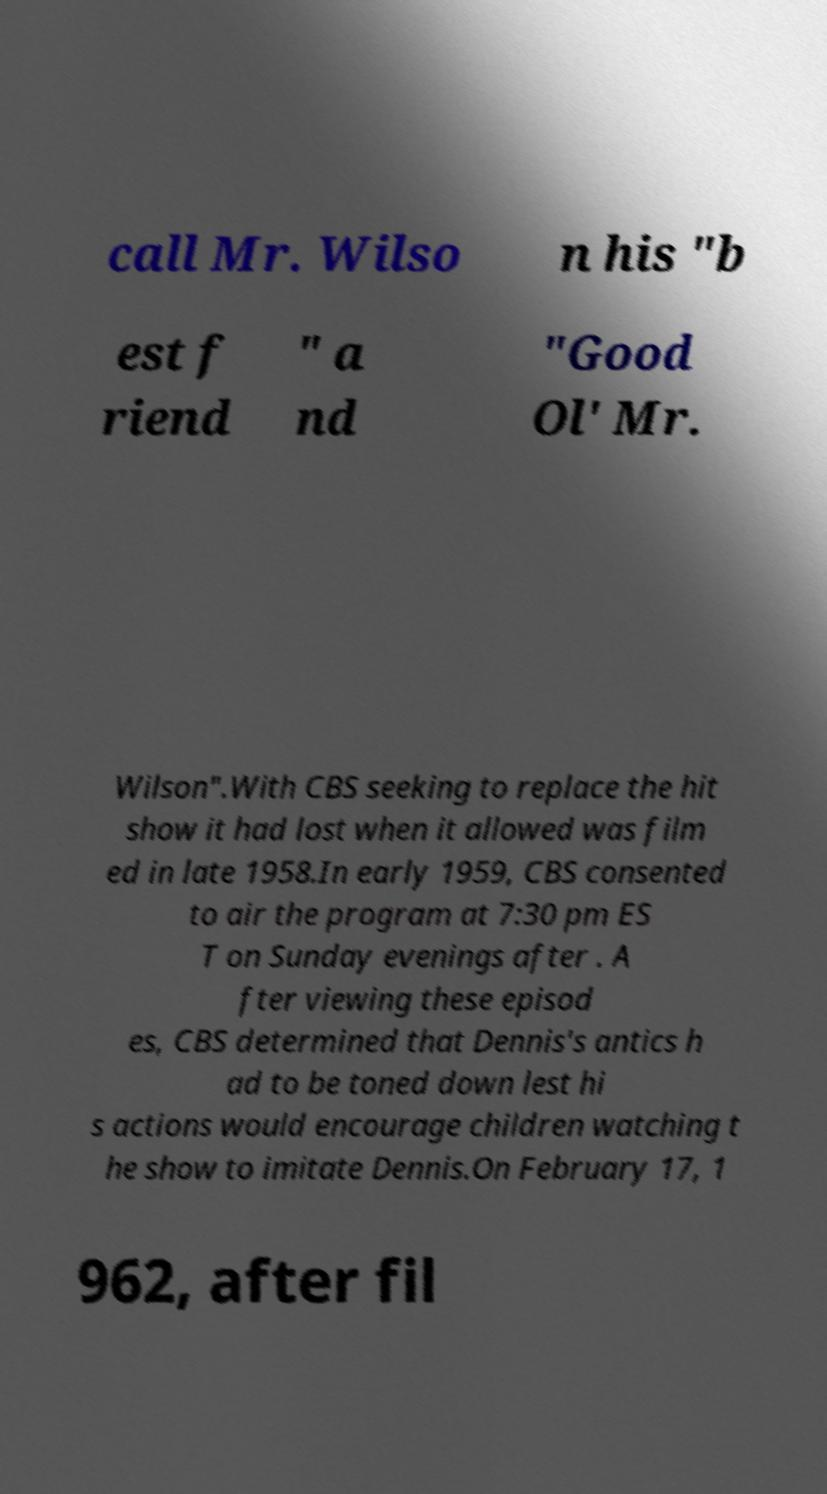What messages or text are displayed in this image? I need them in a readable, typed format. call Mr. Wilso n his "b est f riend " a nd "Good Ol' Mr. Wilson".With CBS seeking to replace the hit show it had lost when it allowed was film ed in late 1958.In early 1959, CBS consented to air the program at 7:30 pm ES T on Sunday evenings after . A fter viewing these episod es, CBS determined that Dennis's antics h ad to be toned down lest hi s actions would encourage children watching t he show to imitate Dennis.On February 17, 1 962, after fil 